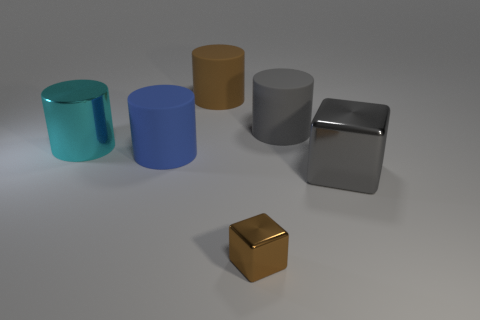Is there any other thing that has the same size as the brown metal block?
Provide a succinct answer. No. The matte cylinder that is the same color as the big metal block is what size?
Provide a succinct answer. Large. What is the object that is both on the right side of the tiny shiny thing and behind the blue cylinder made of?
Offer a terse response. Rubber. Is there a tiny brown block that is in front of the big matte object that is left of the brown thing that is behind the gray metallic thing?
Give a very brief answer. Yes. There is a large gray thing that is made of the same material as the big cyan object; what shape is it?
Ensure brevity in your answer.  Cube. Is the number of big brown rubber cylinders that are on the right side of the big block less than the number of large rubber cylinders to the right of the large brown matte object?
Your response must be concise. Yes. How many small things are brown matte blocks or brown cubes?
Provide a succinct answer. 1. There is a rubber object right of the brown block; is it the same shape as the big metallic object that is in front of the large blue rubber object?
Provide a succinct answer. No. There is a metal thing behind the large rubber object to the left of the big matte thing behind the big gray cylinder; what is its size?
Your answer should be compact. Large. There is a rubber object that is to the left of the brown rubber cylinder; what is its size?
Offer a terse response. Large. 